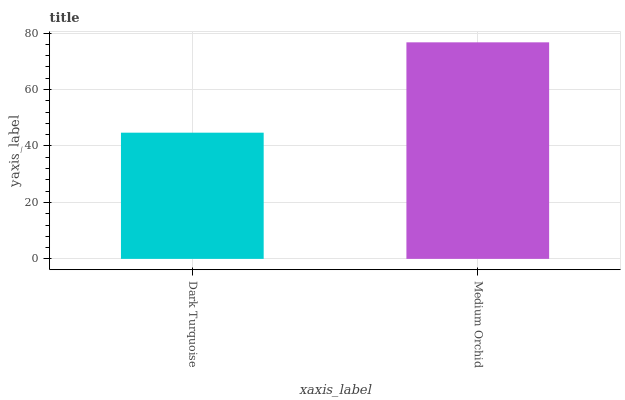Is Dark Turquoise the minimum?
Answer yes or no. Yes. Is Medium Orchid the maximum?
Answer yes or no. Yes. Is Medium Orchid the minimum?
Answer yes or no. No. Is Medium Orchid greater than Dark Turquoise?
Answer yes or no. Yes. Is Dark Turquoise less than Medium Orchid?
Answer yes or no. Yes. Is Dark Turquoise greater than Medium Orchid?
Answer yes or no. No. Is Medium Orchid less than Dark Turquoise?
Answer yes or no. No. Is Medium Orchid the high median?
Answer yes or no. Yes. Is Dark Turquoise the low median?
Answer yes or no. Yes. Is Dark Turquoise the high median?
Answer yes or no. No. Is Medium Orchid the low median?
Answer yes or no. No. 